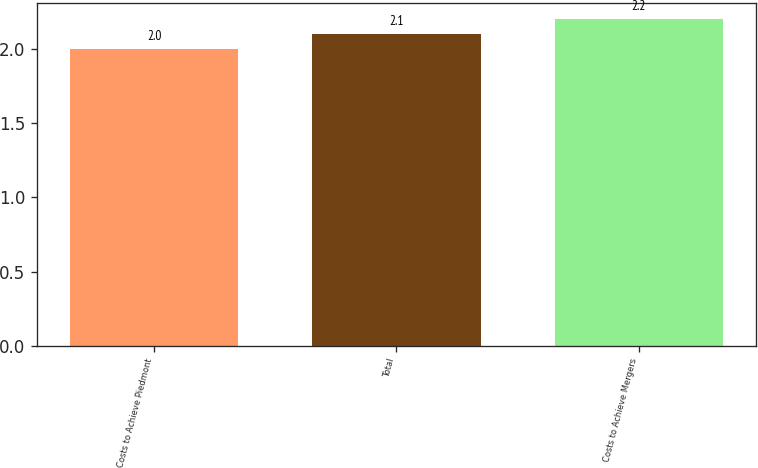<chart> <loc_0><loc_0><loc_500><loc_500><bar_chart><fcel>Costs to Achieve Piedmont<fcel>Total<fcel>Costs to Achieve Mergers<nl><fcel>2<fcel>2.1<fcel>2.2<nl></chart> 